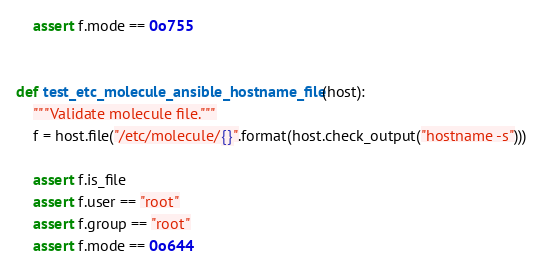Convert code to text. <code><loc_0><loc_0><loc_500><loc_500><_Python_>    assert f.mode == 0o755


def test_etc_molecule_ansible_hostname_file(host):
    """Validate molecule file."""
    f = host.file("/etc/molecule/{}".format(host.check_output("hostname -s")))

    assert f.is_file
    assert f.user == "root"
    assert f.group == "root"
    assert f.mode == 0o644
</code> 